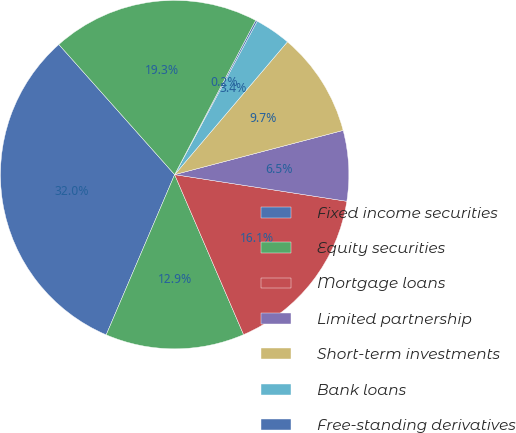Convert chart. <chart><loc_0><loc_0><loc_500><loc_500><pie_chart><fcel>Fixed income securities<fcel>Equity securities<fcel>Mortgage loans<fcel>Limited partnership<fcel>Short-term investments<fcel>Bank loans<fcel>Free-standing derivatives<fcel>Separate accounts<nl><fcel>32.0%<fcel>12.9%<fcel>16.08%<fcel>6.53%<fcel>9.71%<fcel>3.35%<fcel>0.16%<fcel>19.27%<nl></chart> 